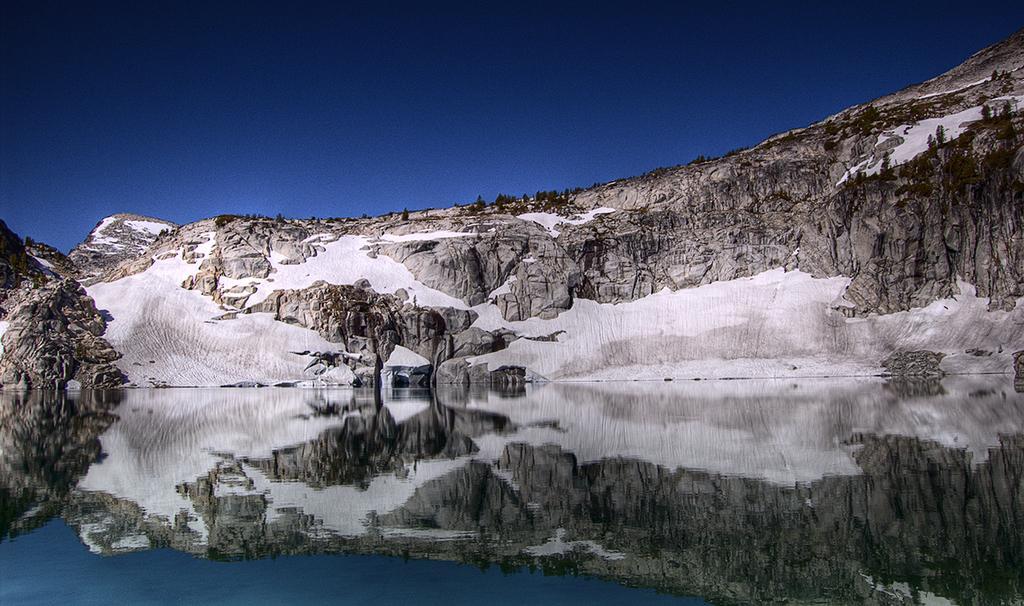How would you summarize this image in a sentence or two? In the image there is a lake in the front with a hill behind it covered with snow and above its sky. 